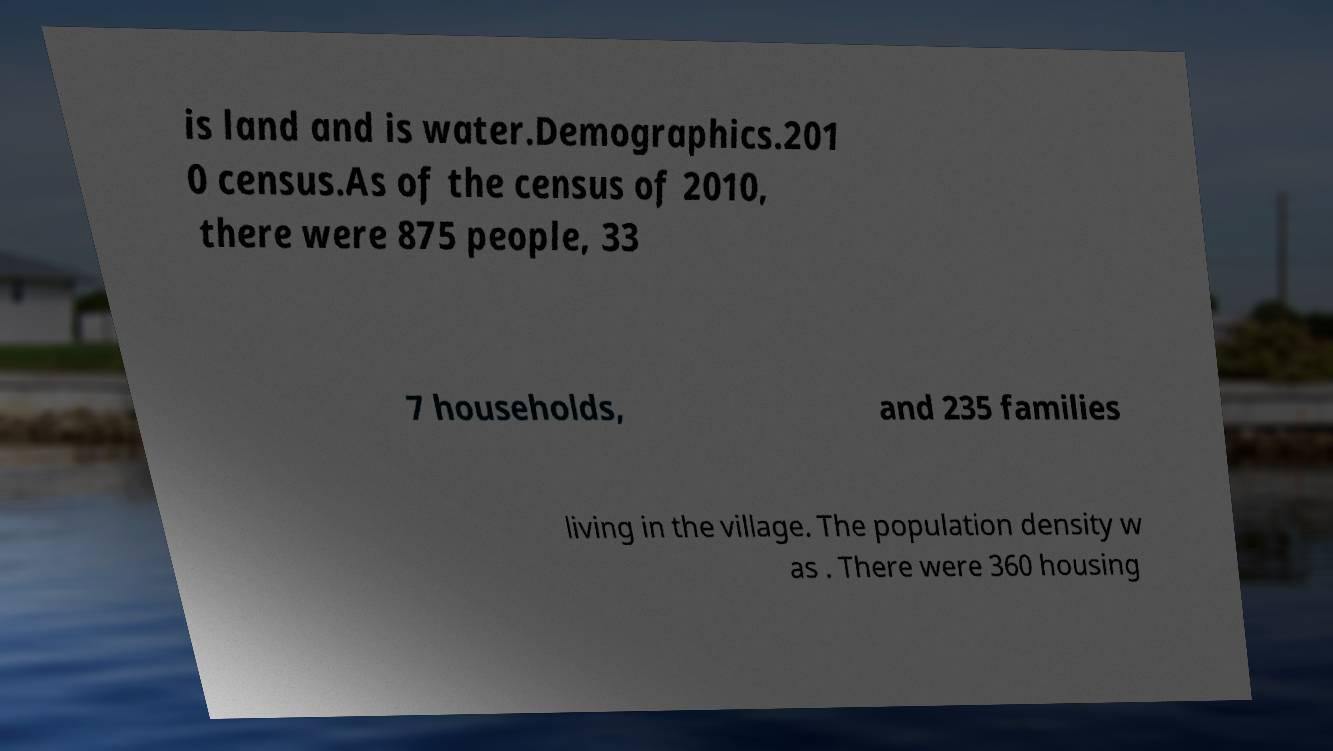Please identify and transcribe the text found in this image. is land and is water.Demographics.201 0 census.As of the census of 2010, there were 875 people, 33 7 households, and 235 families living in the village. The population density w as . There were 360 housing 